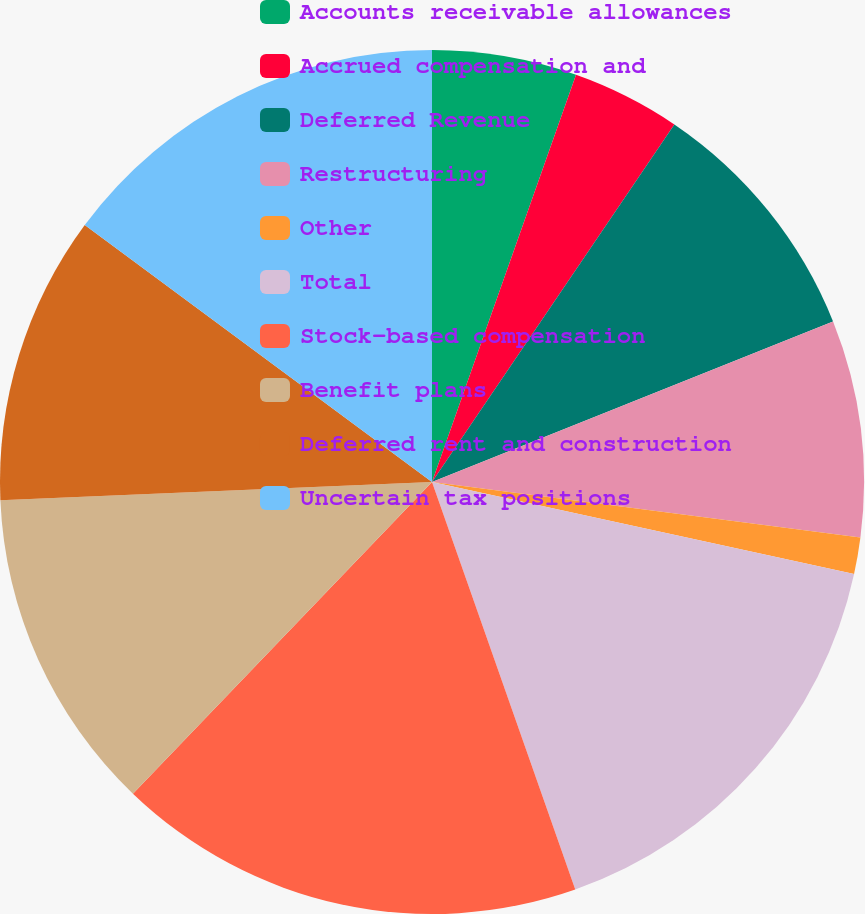Convert chart to OTSL. <chart><loc_0><loc_0><loc_500><loc_500><pie_chart><fcel>Accounts receivable allowances<fcel>Accrued compensation and<fcel>Deferred Revenue<fcel>Restructuring<fcel>Other<fcel>Total<fcel>Stock-based compensation<fcel>Benefit plans<fcel>Deferred rent and construction<fcel>Uncertain tax positions<nl><fcel>5.41%<fcel>4.07%<fcel>9.46%<fcel>8.11%<fcel>1.37%<fcel>16.2%<fcel>17.55%<fcel>12.16%<fcel>10.81%<fcel>14.86%<nl></chart> 